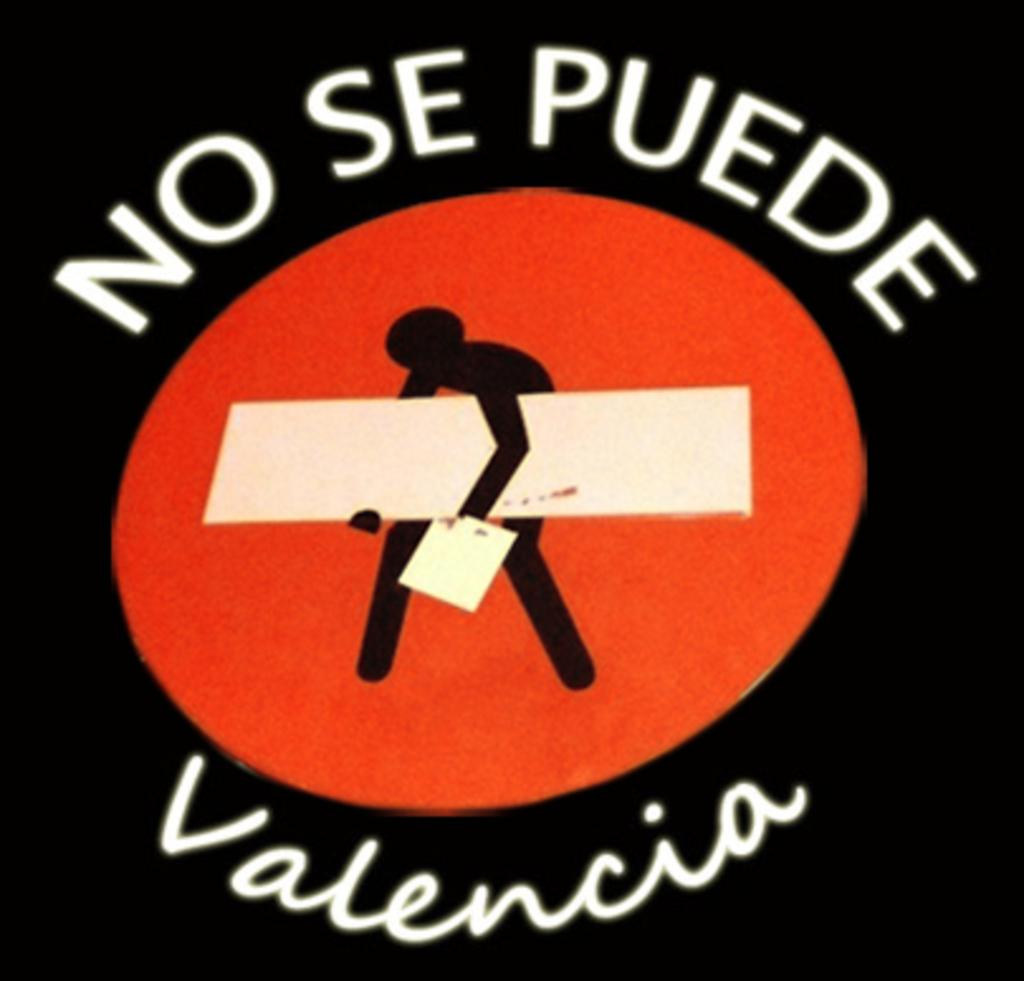Provide a one-sentence caption for the provided image. A sign written in mexican is displayed with a black background and a logo. 